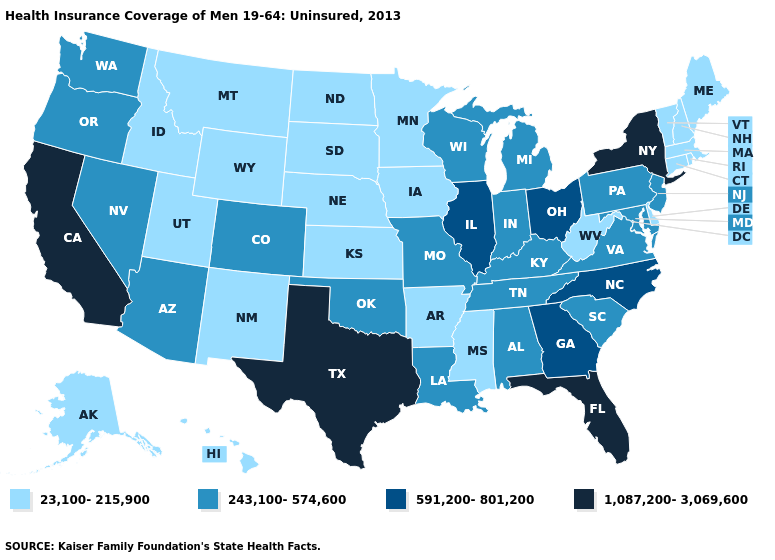What is the highest value in states that border Oregon?
Be succinct. 1,087,200-3,069,600. What is the value of Indiana?
Write a very short answer. 243,100-574,600. Does North Dakota have the same value as Washington?
Keep it brief. No. Does Louisiana have the same value as South Carolina?
Answer briefly. Yes. Does Wisconsin have a lower value than Georgia?
Give a very brief answer. Yes. What is the lowest value in the USA?
Keep it brief. 23,100-215,900. Among the states that border Ohio , does West Virginia have the highest value?
Concise answer only. No. What is the highest value in the USA?
Write a very short answer. 1,087,200-3,069,600. Name the states that have a value in the range 23,100-215,900?
Quick response, please. Alaska, Arkansas, Connecticut, Delaware, Hawaii, Idaho, Iowa, Kansas, Maine, Massachusetts, Minnesota, Mississippi, Montana, Nebraska, New Hampshire, New Mexico, North Dakota, Rhode Island, South Dakota, Utah, Vermont, West Virginia, Wyoming. What is the lowest value in states that border South Carolina?
Be succinct. 591,200-801,200. What is the value of Illinois?
Quick response, please. 591,200-801,200. Does New York have the highest value in the USA?
Quick response, please. Yes. What is the value of Michigan?
Answer briefly. 243,100-574,600. What is the lowest value in the USA?
Give a very brief answer. 23,100-215,900. What is the value of Wyoming?
Short answer required. 23,100-215,900. 